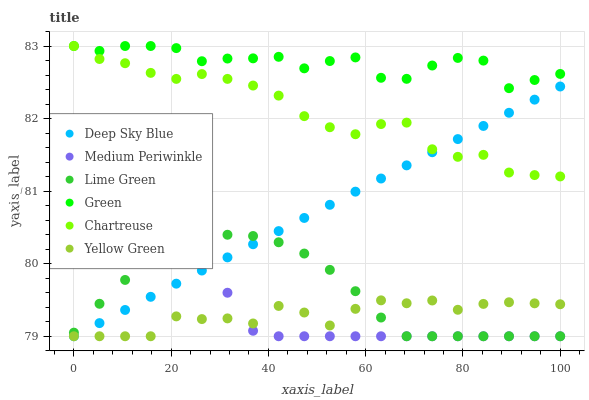Does Yellow Green have the minimum area under the curve?
Answer yes or no. Yes. Does Green have the maximum area under the curve?
Answer yes or no. Yes. Does Medium Periwinkle have the minimum area under the curve?
Answer yes or no. No. Does Medium Periwinkle have the maximum area under the curve?
Answer yes or no. No. Is Deep Sky Blue the smoothest?
Answer yes or no. Yes. Is Green the roughest?
Answer yes or no. Yes. Is Medium Periwinkle the smoothest?
Answer yes or no. No. Is Medium Periwinkle the roughest?
Answer yes or no. No. Does Yellow Green have the lowest value?
Answer yes or no. Yes. Does Chartreuse have the lowest value?
Answer yes or no. No. Does Green have the highest value?
Answer yes or no. Yes. Does Medium Periwinkle have the highest value?
Answer yes or no. No. Is Lime Green less than Chartreuse?
Answer yes or no. Yes. Is Chartreuse greater than Yellow Green?
Answer yes or no. Yes. Does Lime Green intersect Medium Periwinkle?
Answer yes or no. Yes. Is Lime Green less than Medium Periwinkle?
Answer yes or no. No. Is Lime Green greater than Medium Periwinkle?
Answer yes or no. No. Does Lime Green intersect Chartreuse?
Answer yes or no. No. 